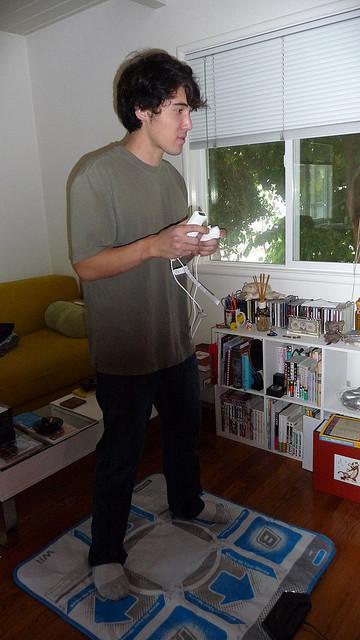How many airplanes have a vehicle under their wing?
Give a very brief answer. 0. 